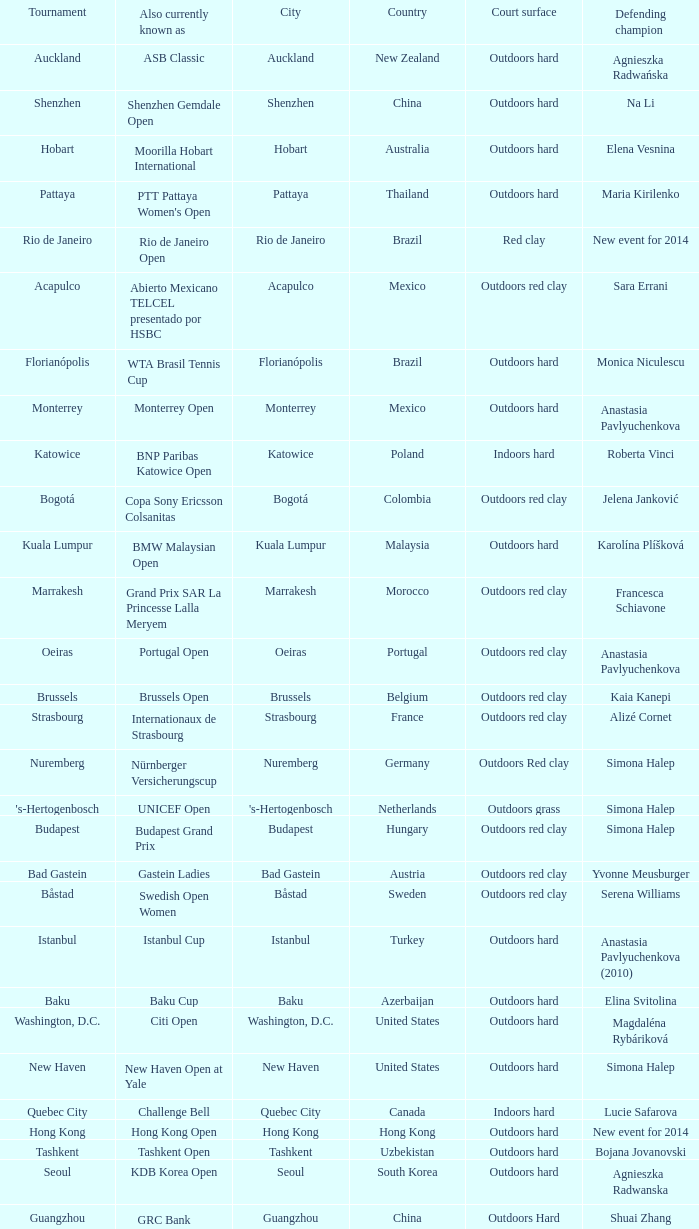How many tournaments are also currently known as the hp open? 1.0. 